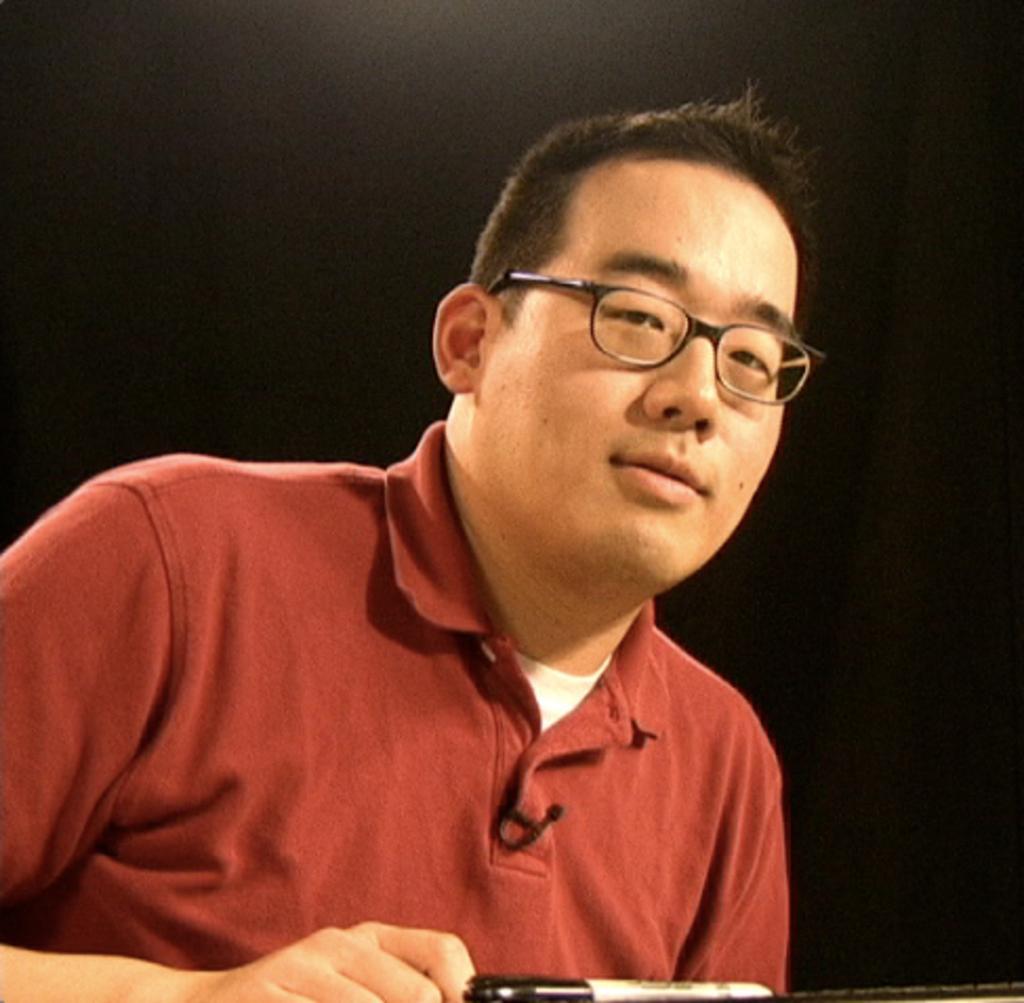How would you summarize this image in a sentence or two? In this picture we can see a man smiling and he wore red color T-Shirt, spectacles and he is holding something in his hand. 